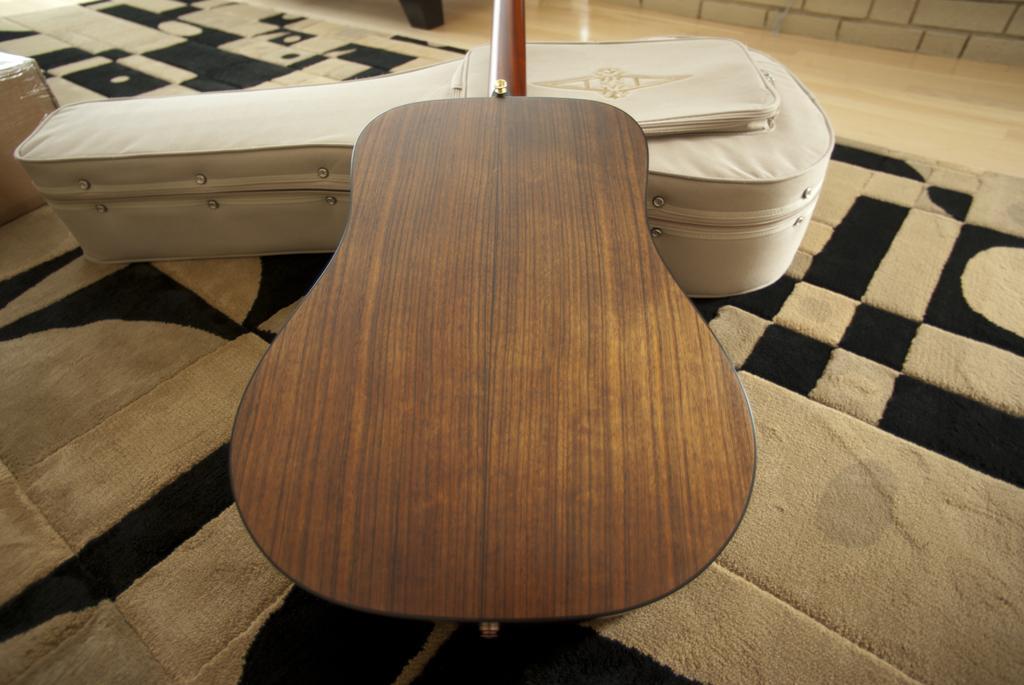How would you summarize this image in a sentence or two? In this picture there is a guitar and guitar bag. There is a carpet. 